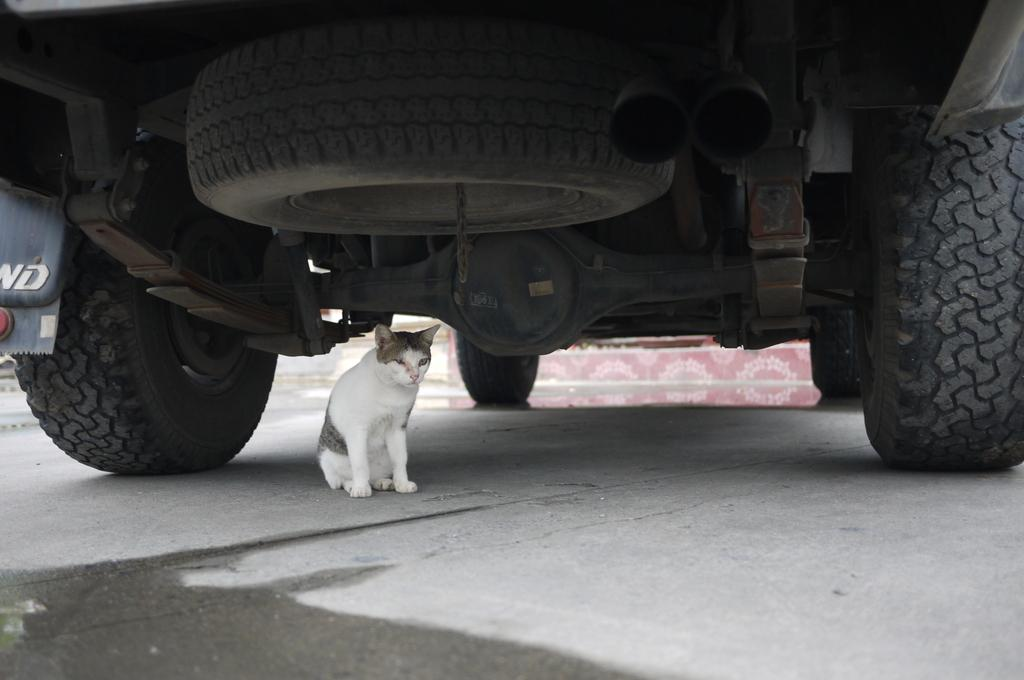What type of vehicle is in the image? There is a vehicle in the image, but the specific type is not mentioned. What feature is present on the vehicle? The vehicle has a smoke pipe. What part of the vehicle is designed for movement? The vehicle has tires, which are designed for movement. Are the tires attached to the vehicle? Yes, the tires are fixed to the vehicle. What else can be seen in the image besides the vehicle? There is a cat sitting on a path in the image. What type of thread is being used by the society in the image? There is no mention of thread or society in the image; it features a vehicle and a cat sitting on a path. What is the cat learning in the image? There is no indication that the cat is learning anything in the image; it is simply sitting on a path. 